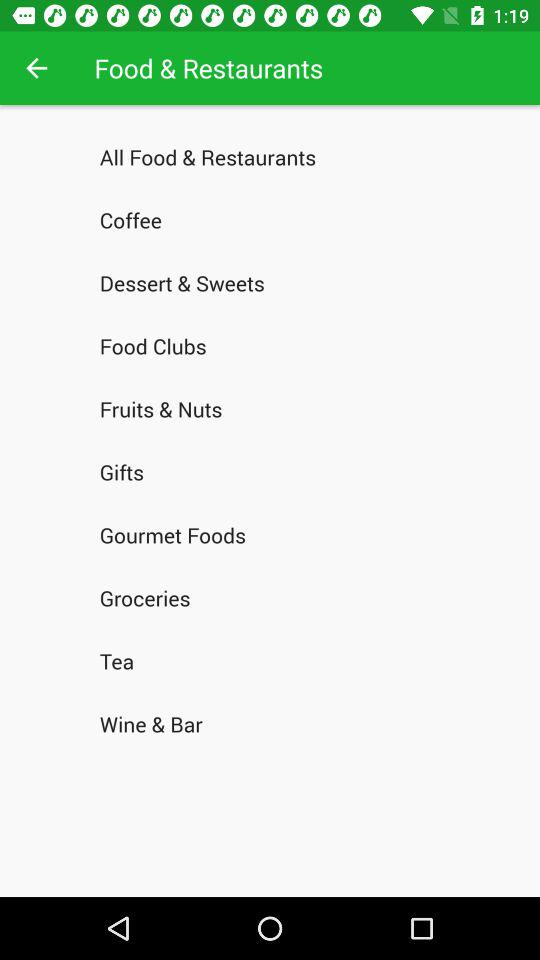How many food and restaurants categories are available?
Answer the question using a single word or phrase. 10 